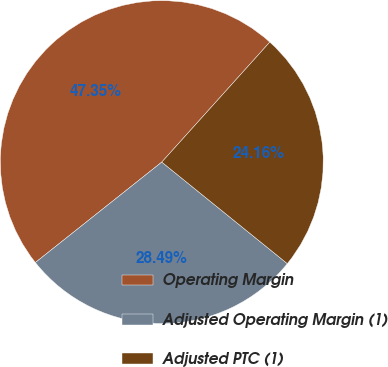Convert chart. <chart><loc_0><loc_0><loc_500><loc_500><pie_chart><fcel>Operating Margin<fcel>Adjusted Operating Margin (1)<fcel>Adjusted PTC (1)<nl><fcel>47.35%<fcel>28.49%<fcel>24.16%<nl></chart> 